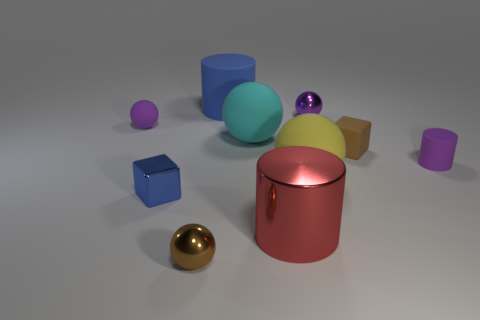The purple matte object that is in front of the small rubber sphere has what shape? cylinder 